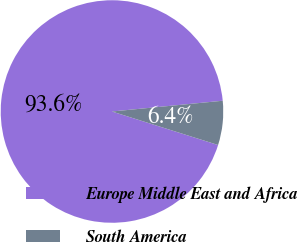<chart> <loc_0><loc_0><loc_500><loc_500><pie_chart><fcel>Europe Middle East and Africa<fcel>South America<nl><fcel>93.59%<fcel>6.41%<nl></chart> 